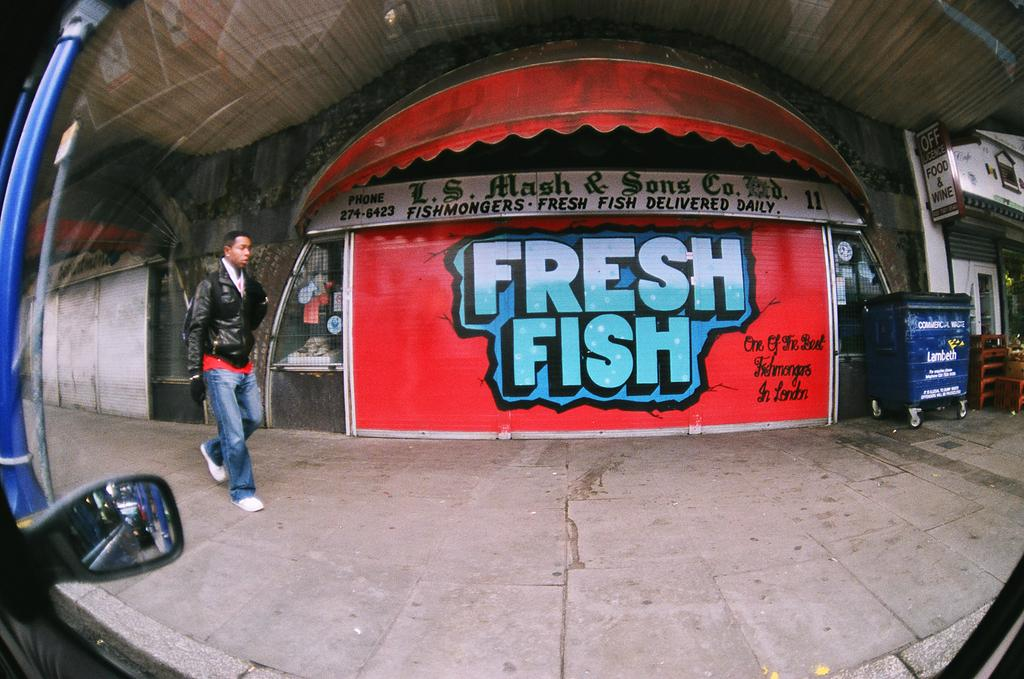What type of path is visible in the image? There is a footpath in the image. What is the man in the image doing? A man is walking on the footpath. What can be seen in the background of the image? There is a shop in the background of the image. What is written on the shop? Text is written on the shop. How many rings are visible on the man's throne in the image? There is no throne or rings present in the image. What type of error can be seen on the shop's sign in the image? There is no error mentioned on the shop's sign in the image. 